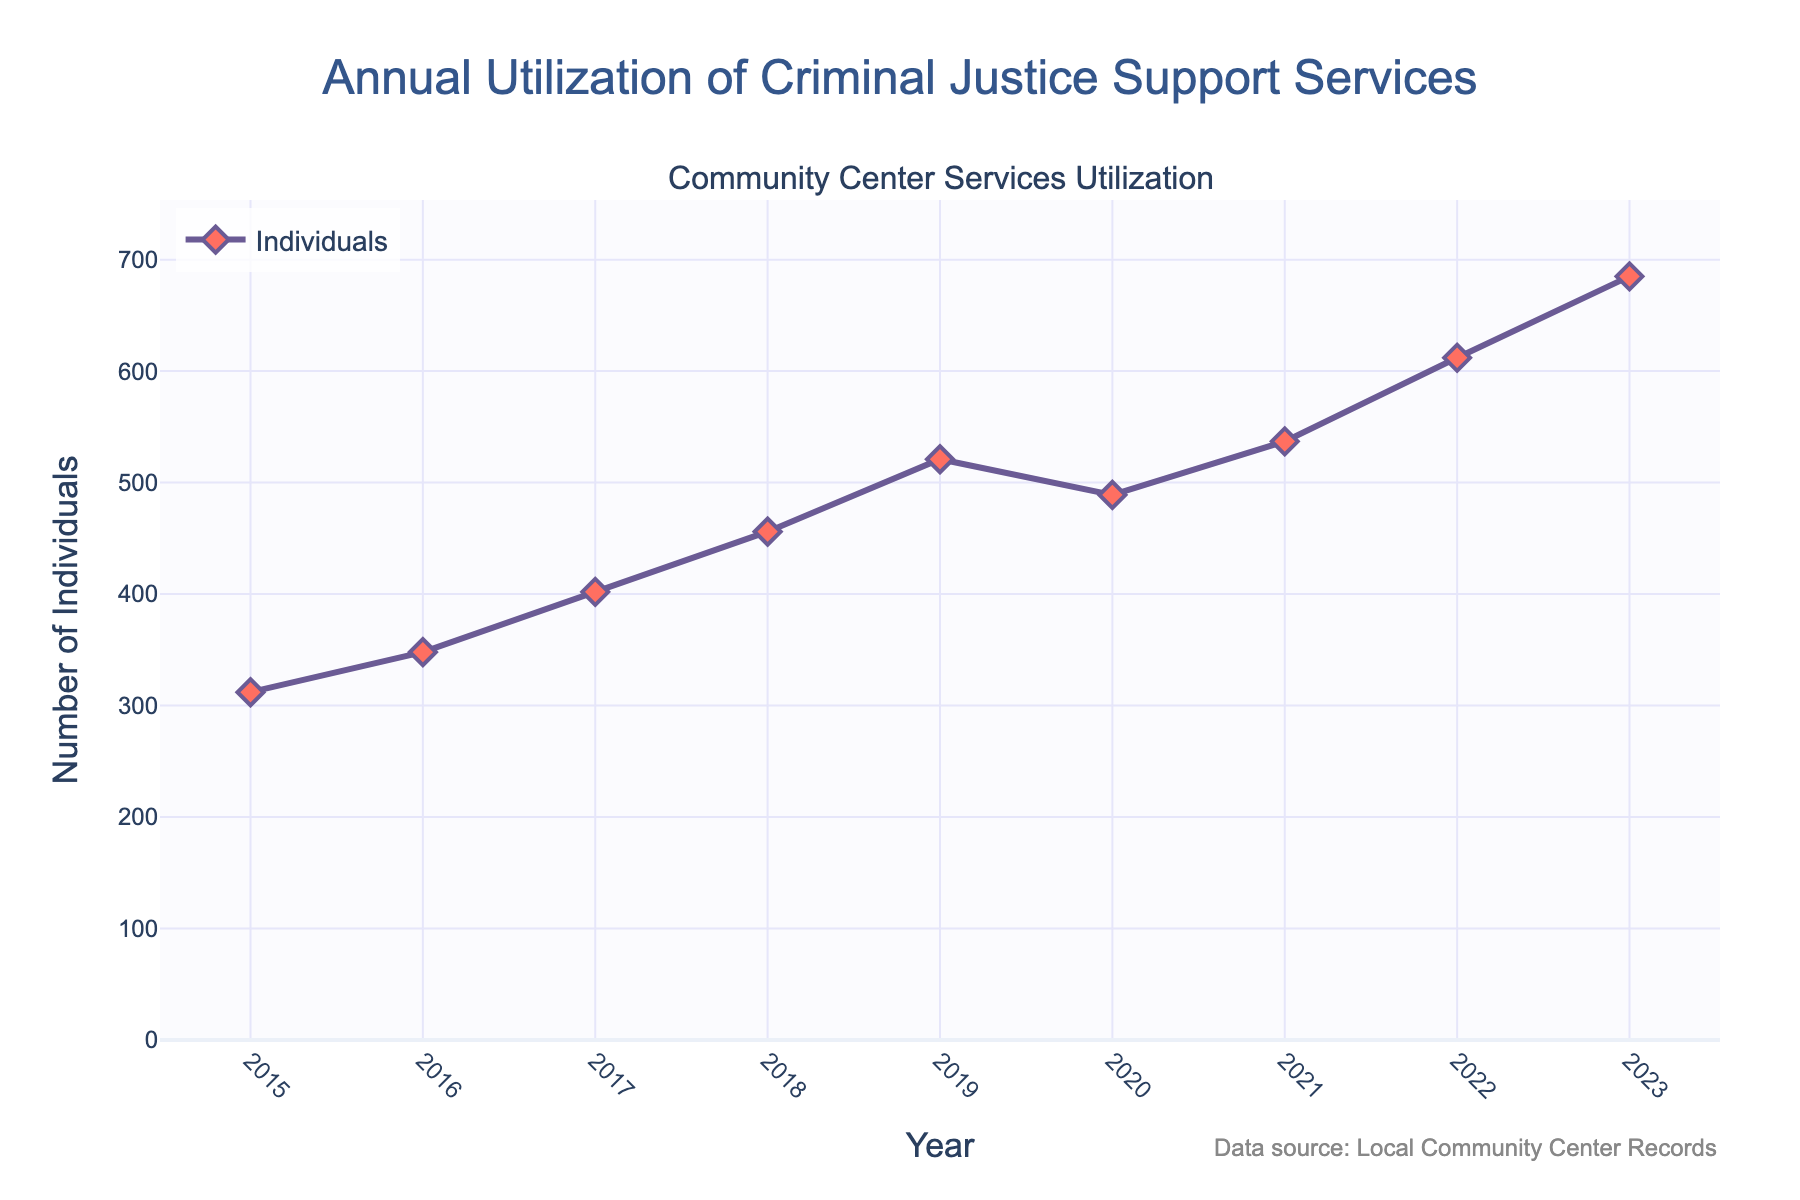What's the total number of individuals accessing services over the entire period? Sum the number of individuals accessing services from 2015 to 2023: 312 + 348 + 402 + 456 + 521 + 489 + 537 + 612 + 685 = 4362
Answer: 4362 Which year had the steepest increase in the number of individuals compared to the previous year? Calculate the differences between consecutive years: 348 - 312 = 36, 402 - 348 = 54, 456 - 402 = 54, 521 - 456 = 65, 489 - 521 = -32, 537 - 489 = 48, 612 - 537 = 75, 685 - 612 = 73. The largest difference is between 2021 and 2022 with an increase of 75 individuals
Answer: 2022 In which years did the number of individuals accessing services decrease? Identify the years where the number is lower than the previous year: 2020 (489) is less than 2019 (521)
Answer: 2020 What is the average number of individuals accessing services annually over the given period? Calculate the total number of individuals (4362) and divide by the number of years (9): 4362 / 9 = 484.67
Answer: 484.67 What was the percentage growth in the number of individuals accessing services from 2015 to 2023? Calculate the percentage increase: ((685 - 312) / 312) * 100% = 119.87%
Answer: 119.87% Which year saw the highest number of individuals accessing services, and what was the count? Identify the highest count: 685 in 2023
Answer: 2023, 685 How did the number of individuals accessing services change from 2016 to 2017? Subtract the number in 2016 from 2017: 402 - 348 = 54
Answer: Increased by 54 What is the median number of individuals accessing services over the years provided? List the values in ascending order: 312, 348, 402, 456, 489, 521, 537, 612, 685. The middle value is 489
Answer: 489 How many years had more than 500 individuals accessing services? Identify the years with more than 500 individuals: 2019, 2020, 2021, 2022, 2023 (5 years)
Answer: 5 